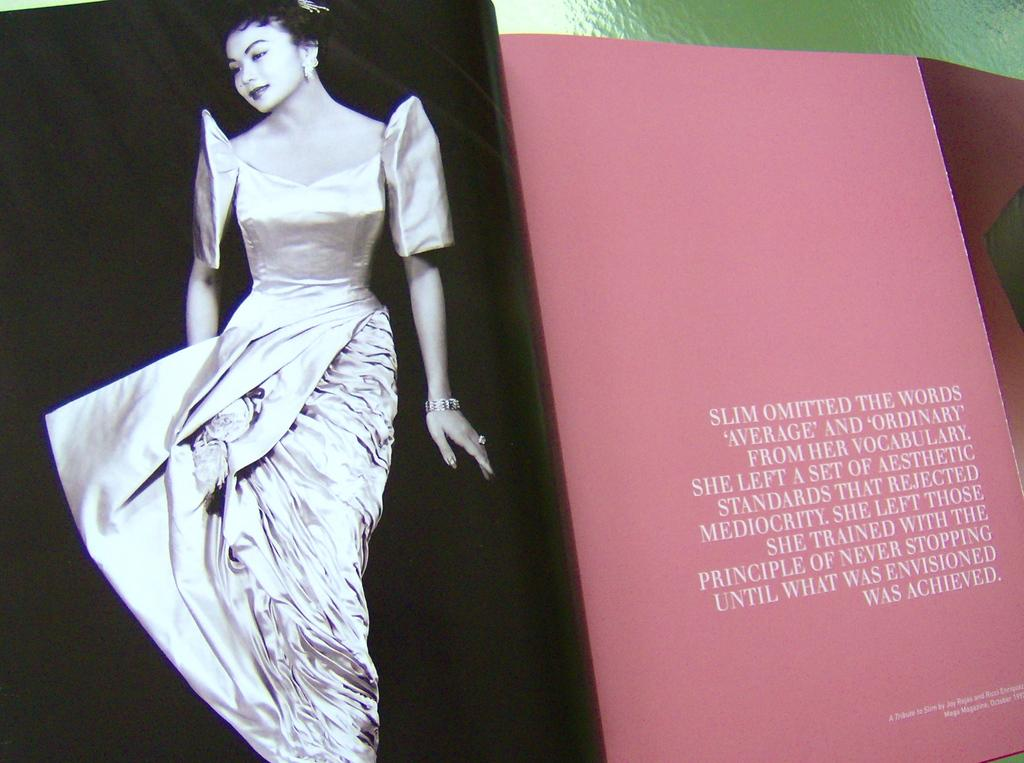Provide a one-sentence caption for the provided image. A magazine with a picture of a woman says "Slim omitted the words average and ordinary". 